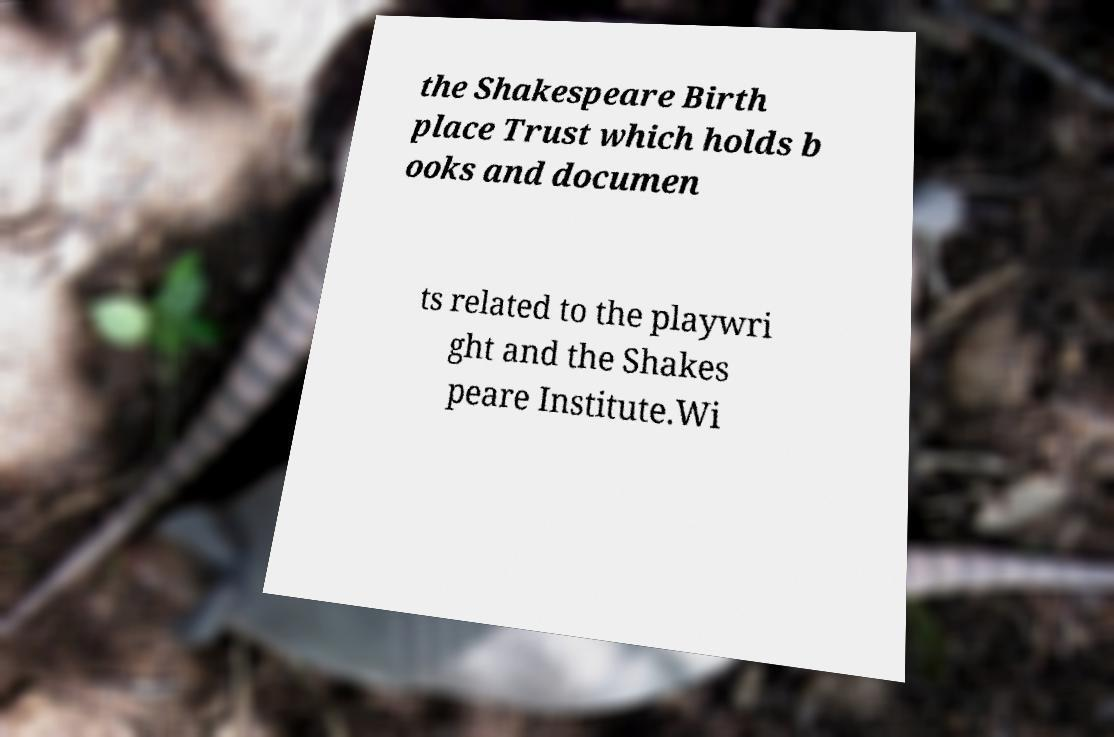Can you accurately transcribe the text from the provided image for me? the Shakespeare Birth place Trust which holds b ooks and documen ts related to the playwri ght and the Shakes peare Institute.Wi 